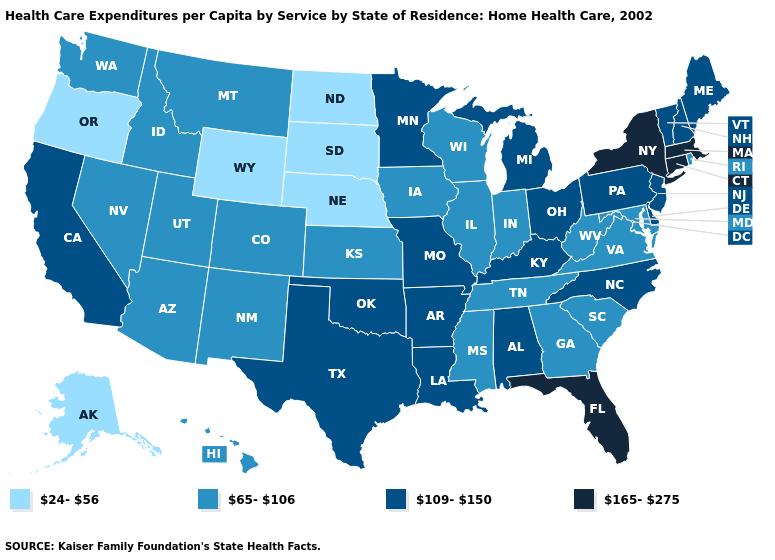Does the map have missing data?
Give a very brief answer. No. Name the states that have a value in the range 165-275?
Answer briefly. Connecticut, Florida, Massachusetts, New York. Is the legend a continuous bar?
Give a very brief answer. No. Which states have the lowest value in the USA?
Quick response, please. Alaska, Nebraska, North Dakota, Oregon, South Dakota, Wyoming. What is the value of New Hampshire?
Give a very brief answer. 109-150. Name the states that have a value in the range 65-106?
Write a very short answer. Arizona, Colorado, Georgia, Hawaii, Idaho, Illinois, Indiana, Iowa, Kansas, Maryland, Mississippi, Montana, Nevada, New Mexico, Rhode Island, South Carolina, Tennessee, Utah, Virginia, Washington, West Virginia, Wisconsin. Name the states that have a value in the range 165-275?
Write a very short answer. Connecticut, Florida, Massachusetts, New York. Which states have the lowest value in the USA?
Answer briefly. Alaska, Nebraska, North Dakota, Oregon, South Dakota, Wyoming. Name the states that have a value in the range 109-150?
Give a very brief answer. Alabama, Arkansas, California, Delaware, Kentucky, Louisiana, Maine, Michigan, Minnesota, Missouri, New Hampshire, New Jersey, North Carolina, Ohio, Oklahoma, Pennsylvania, Texas, Vermont. What is the value of Mississippi?
Quick response, please. 65-106. What is the value of Georgia?
Write a very short answer. 65-106. What is the lowest value in the MidWest?
Write a very short answer. 24-56. What is the value of Rhode Island?
Give a very brief answer. 65-106. What is the value of Oregon?
Write a very short answer. 24-56. Name the states that have a value in the range 165-275?
Be succinct. Connecticut, Florida, Massachusetts, New York. 